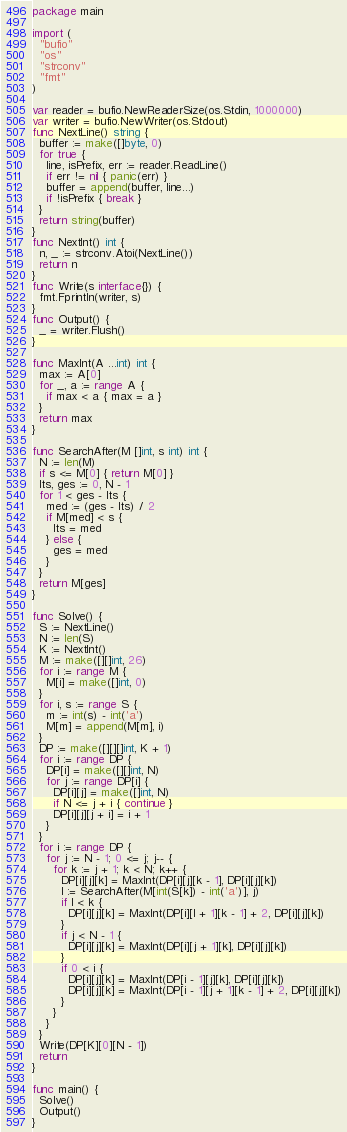<code> <loc_0><loc_0><loc_500><loc_500><_Go_>package main

import (
  "bufio"
  "os"
  "strconv"
  "fmt"
)

var reader = bufio.NewReaderSize(os.Stdin, 1000000)
var writer = bufio.NewWriter(os.Stdout)
func NextLine() string {
  buffer := make([]byte, 0)
  for true {
    line, isPrefix, err := reader.ReadLine()
    if err != nil { panic(err) }
    buffer = append(buffer, line...)
    if !isPrefix { break }
  }
  return string(buffer)
}
func NextInt() int {
  n, _ := strconv.Atoi(NextLine())
  return n
}
func Write(s interface{}) {
  fmt.Fprintln(writer, s)
}
func Output() {
  _ = writer.Flush()
}

func MaxInt(A ...int) int {
  max := A[0]
  for _, a := range A {
    if max < a { max = a }
  }
  return max
}

func SearchAfter(M []int, s int) int {
  N := len(M)
  if s <= M[0] { return M[0] }
  lts, ges := 0, N - 1
  for 1 < ges - lts {
    med := (ges - lts) / 2
    if M[med] < s {
      lts = med
    } else {
      ges = med
    }
  }
  return M[ges]
}

func Solve() {
  S := NextLine()
  N := len(S)
  K := NextInt()
  M := make([][]int, 26)
  for i := range M {
    M[i] = make([]int, 0)
  }
  for i, s := range S {
    m := int(s) - int('a')
    M[m] = append(M[m], i)
  }
  DP := make([][][]int, K + 1)
  for i := range DP {
    DP[i] = make([][]int, N)
    for j := range DP[i] {
      DP[i][j] = make([]int, N)
      if N <= j + i { continue }
      DP[i][j][j + i] = i + 1
    }
  }
  for i := range DP {
    for j := N - 1; 0 <= j; j-- {
      for k := j + 1; k < N; k++ {
        DP[i][j][k] = MaxInt(DP[i][j][k - 1], DP[i][j][k])
        l := SearchAfter(M[int(S[k]) - int('a')], j)
        if l < k {
          DP[i][j][k] = MaxInt(DP[i][l + 1][k - 1] + 2, DP[i][j][k])
        }
        if j < N - 1 {
          DP[i][j][k] = MaxInt(DP[i][j + 1][k], DP[i][j][k])
        }
        if 0 < i {
          DP[i][j][k] = MaxInt(DP[i - 1][j][k], DP[i][j][k])
          DP[i][j][k] = MaxInt(DP[i - 1][j + 1][k - 1] + 2, DP[i][j][k])
        }
      }
    }
  }
  Write(DP[K][0][N - 1])
  return
}

func main() {
  Solve()
  Output()
}</code> 